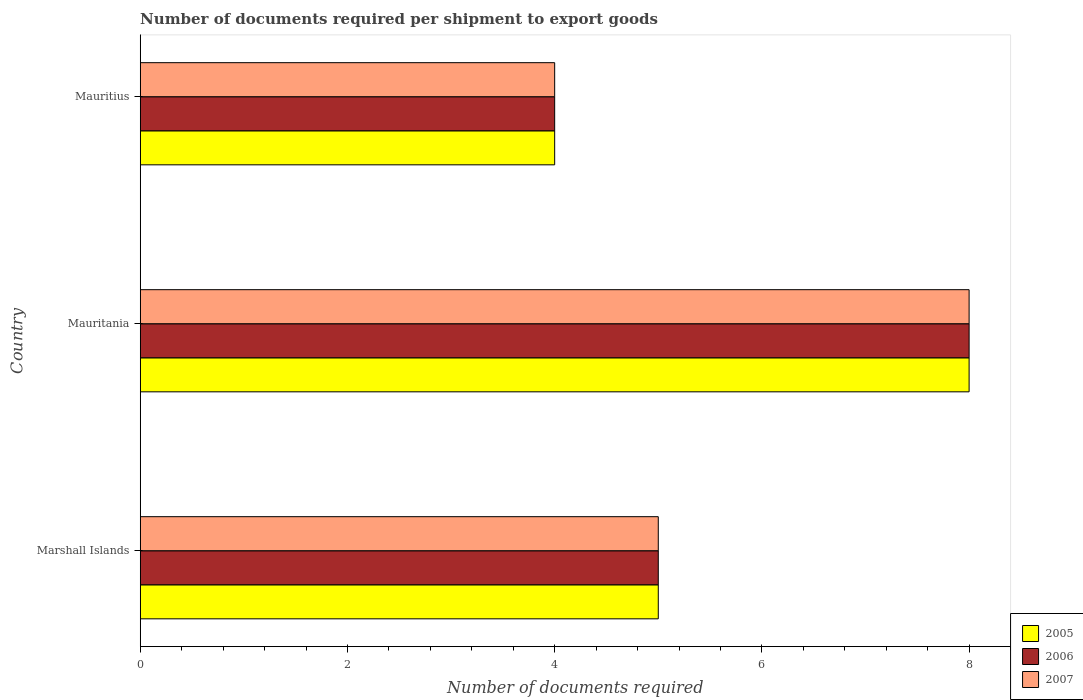How many bars are there on the 3rd tick from the top?
Offer a terse response. 3. What is the label of the 3rd group of bars from the top?
Your response must be concise. Marshall Islands. Across all countries, what is the minimum number of documents required per shipment to export goods in 2005?
Give a very brief answer. 4. In which country was the number of documents required per shipment to export goods in 2005 maximum?
Provide a succinct answer. Mauritania. In which country was the number of documents required per shipment to export goods in 2006 minimum?
Offer a very short reply. Mauritius. What is the difference between the number of documents required per shipment to export goods in 2007 in Marshall Islands and that in Mauritius?
Your response must be concise. 1. What is the average number of documents required per shipment to export goods in 2007 per country?
Offer a terse response. 5.67. What is the difference between the number of documents required per shipment to export goods in 2006 and number of documents required per shipment to export goods in 2005 in Mauritius?
Make the answer very short. 0. What is the ratio of the number of documents required per shipment to export goods in 2005 in Marshall Islands to that in Mauritania?
Give a very brief answer. 0.62. Is the number of documents required per shipment to export goods in 2006 in Mauritania less than that in Mauritius?
Ensure brevity in your answer.  No. What is the difference between the highest and the second highest number of documents required per shipment to export goods in 2006?
Give a very brief answer. 3. What does the 1st bar from the top in Marshall Islands represents?
Provide a succinct answer. 2007. Is it the case that in every country, the sum of the number of documents required per shipment to export goods in 2005 and number of documents required per shipment to export goods in 2007 is greater than the number of documents required per shipment to export goods in 2006?
Ensure brevity in your answer.  Yes. How many bars are there?
Provide a succinct answer. 9. Are all the bars in the graph horizontal?
Give a very brief answer. Yes. What is the difference between two consecutive major ticks on the X-axis?
Provide a short and direct response. 2. Are the values on the major ticks of X-axis written in scientific E-notation?
Offer a very short reply. No. Does the graph contain grids?
Offer a terse response. No. Where does the legend appear in the graph?
Make the answer very short. Bottom right. What is the title of the graph?
Keep it short and to the point. Number of documents required per shipment to export goods. Does "2002" appear as one of the legend labels in the graph?
Keep it short and to the point. No. What is the label or title of the X-axis?
Ensure brevity in your answer.  Number of documents required. What is the Number of documents required of 2006 in Marshall Islands?
Offer a very short reply. 5. What is the Number of documents required of 2007 in Marshall Islands?
Offer a terse response. 5. What is the Number of documents required in 2006 in Mauritania?
Make the answer very short. 8. What is the Number of documents required of 2005 in Mauritius?
Your answer should be very brief. 4. Across all countries, what is the maximum Number of documents required in 2006?
Provide a succinct answer. 8. Across all countries, what is the minimum Number of documents required in 2005?
Offer a very short reply. 4. Across all countries, what is the minimum Number of documents required of 2007?
Offer a terse response. 4. What is the total Number of documents required of 2005 in the graph?
Ensure brevity in your answer.  17. What is the difference between the Number of documents required in 2006 in Marshall Islands and that in Mauritania?
Offer a very short reply. -3. What is the difference between the Number of documents required in 2006 in Marshall Islands and that in Mauritius?
Keep it short and to the point. 1. What is the difference between the Number of documents required of 2005 in Mauritania and that in Mauritius?
Offer a very short reply. 4. What is the difference between the Number of documents required of 2006 in Mauritania and that in Mauritius?
Your response must be concise. 4. What is the difference between the Number of documents required in 2007 in Mauritania and that in Mauritius?
Keep it short and to the point. 4. What is the difference between the Number of documents required of 2005 in Marshall Islands and the Number of documents required of 2006 in Mauritania?
Keep it short and to the point. -3. What is the difference between the Number of documents required in 2005 in Marshall Islands and the Number of documents required in 2006 in Mauritius?
Your response must be concise. 1. What is the difference between the Number of documents required of 2005 in Marshall Islands and the Number of documents required of 2007 in Mauritius?
Provide a succinct answer. 1. What is the difference between the Number of documents required of 2006 in Marshall Islands and the Number of documents required of 2007 in Mauritius?
Keep it short and to the point. 1. What is the difference between the Number of documents required of 2005 in Mauritania and the Number of documents required of 2007 in Mauritius?
Ensure brevity in your answer.  4. What is the average Number of documents required in 2005 per country?
Provide a succinct answer. 5.67. What is the average Number of documents required in 2006 per country?
Make the answer very short. 5.67. What is the average Number of documents required of 2007 per country?
Your answer should be very brief. 5.67. What is the difference between the Number of documents required of 2005 and Number of documents required of 2006 in Marshall Islands?
Ensure brevity in your answer.  0. What is the difference between the Number of documents required in 2005 and Number of documents required in 2007 in Marshall Islands?
Give a very brief answer. 0. What is the difference between the Number of documents required of 2006 and Number of documents required of 2007 in Marshall Islands?
Ensure brevity in your answer.  0. What is the difference between the Number of documents required in 2005 and Number of documents required in 2006 in Mauritius?
Provide a short and direct response. 0. What is the ratio of the Number of documents required of 2007 in Marshall Islands to that in Mauritania?
Give a very brief answer. 0.62. What is the ratio of the Number of documents required in 2006 in Marshall Islands to that in Mauritius?
Offer a terse response. 1.25. What is the difference between the highest and the second highest Number of documents required in 2006?
Offer a terse response. 3. What is the difference between the highest and the second highest Number of documents required in 2007?
Provide a succinct answer. 3. What is the difference between the highest and the lowest Number of documents required of 2005?
Give a very brief answer. 4. What is the difference between the highest and the lowest Number of documents required in 2006?
Your response must be concise. 4. 